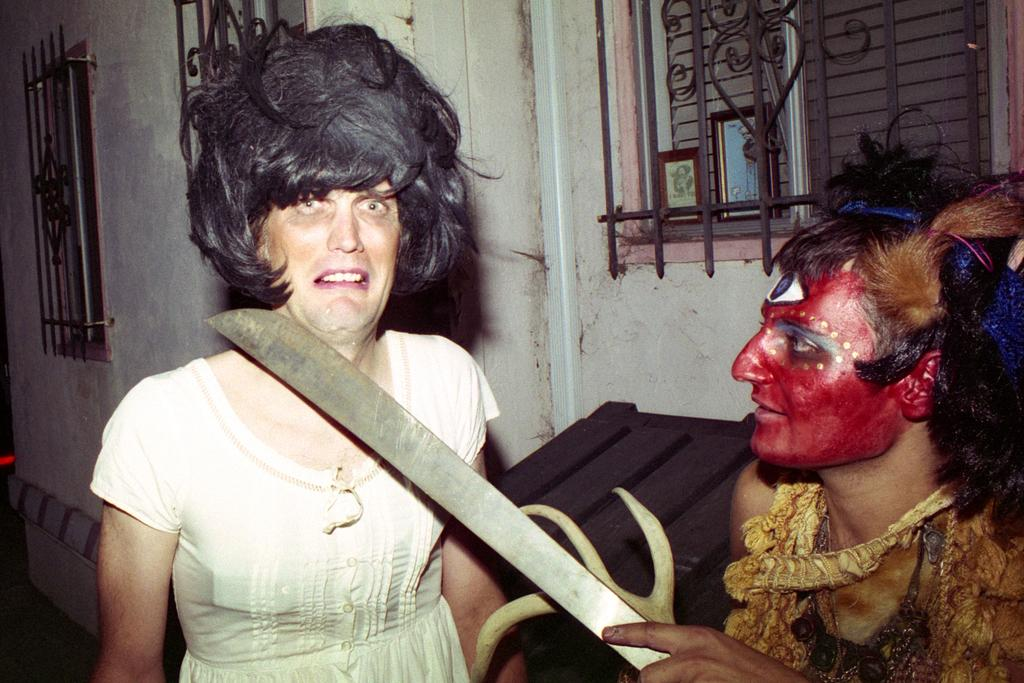How many people are in the image? There are two people in the foreground of the image. What can be seen in the background of the image? There is a wall in the background of the image. What features does the wall have? The wall has windows and grills. What color is the horse painted in the image? There is no horse present in the image, so it cannot be painted or have a specific color. 